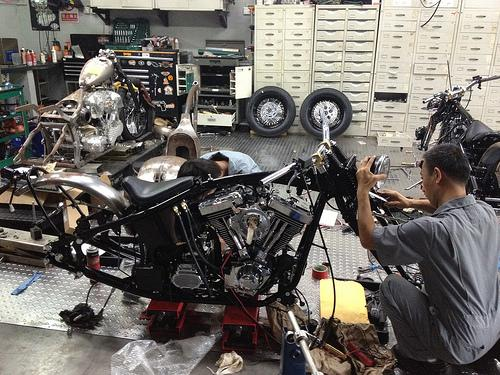Tell me about the working environment in the image. It's the interior of a motorcycle shop with tools, parts, and cabinets around, and a mechanic working on a partially disassembled motorcycle. What can be seen leaning against the cabinets in the image? Two black tires Identify the item still attached to the partially disassembled motorcycle. The seat of the motorcycle What is the mechanic doing in the image? The mechanic is working on the motorcycle, squatted on the floor amidst scattered motorcycle parts. Name some of the storage solutions present in the motorcycle shop. Cabinets, drawers, and a tool chest against the wall What are some of the objects that are scattered on the floor? Motorcycle parts, a wheel, and a motorcycle frame Find the type of shoes the man in the image is wearing. Black shoes What's the status of the motorcycle that the mechanic is working on? It is partially disassembled and unarmed. What type of professional can be seen working in this image? Motorcycle mechanic Describe the appearance of the mechanic in the picture. The mechanic has short black hair, wearing gray overalls, and black shoes. Describe the type of shoes the man is wearing. The man is wearing black shoes. Does the person in the image have long curly hair? The image caption mentions "short black hair," so asking about long curly hair would be misleading. Can you see any tools on the mechanic's workbench? There is no mention of a workbench in the image captions, only cabinets, shelves, and tools scattered on the floor, so asking about a workbench would be misleading. In the image, is the seat of the motorcycle still on? Yes, the seat of the motorcycle is still on. Are there any cans visible in the image? If yes, what color are they? Yes, there are red cans on the counter. What are the cabinets in the image used for? The cabinets are used for storing various tools and parts. Is the mechanic wearing a red outfit in the image? There is no mention of a red outfit in the image captions, so describing the mechanic as wearing red would be misleading. What is the person in the image doing? The person is a motorcycle mechanic squatted on the floor working on a motorcycle. What type of floor covering is in the image? There is a metal floor covering. What type of outfit is the man wearing? The man is wearing gray overalls which is a one-piece outfit. Explain the general scenario of the image. The image shows the interior of a motorcycle shop, where a mechanic is working on a partially disassembled motorcycle, and various tools and parts are stored in cabinets. Is the motorcycle mechanic wearing overalls? If so, what color is it? Yes, the mechanic is wearing gray overalls. Is there a blue cabinet of drawers present in the image? The image captions mention a "large cabinet of drawers," "cabinets used for storing tools and parts," and "white drawers," but no mention of a blue cabinet, so asking about a blue cabinet would be misleading. Which of the following body parts of the person are visible in the image? B) arm Locate the objects that are "rear fender of the motorcycle" and "a large cabinet of drawers". The rear fender of the motorcycle is on the left side of the image, while the large cabinet of drawers is on the right side of the image. Are there any blue tires in the image? No, it's not mentioned in the image. Where are the two tires placed in the image? The two tires are leaning against cabinets. Describe the condition of the motorcycle being worked on. The motorcycle is partially disassembled, with parts scattered on the floor. Find the "white drawers" and describe a nearby object. The white drawers are on a mechanical workshop, and there are two black wheels beside them. Does the image feature an assembled or disassembled motorcycle? The image features a partially disassembled motorcycle. Identify the color of the man's hair. The man's hair is short and black. What activity is the mechanic involved in? The mechanic is working on a motorcycle. Can you find any green bottles on the shelf? The image caption mentions "several bottles" but does not mention any color. Assuming that the bottles are green would be misleading without proper information. 